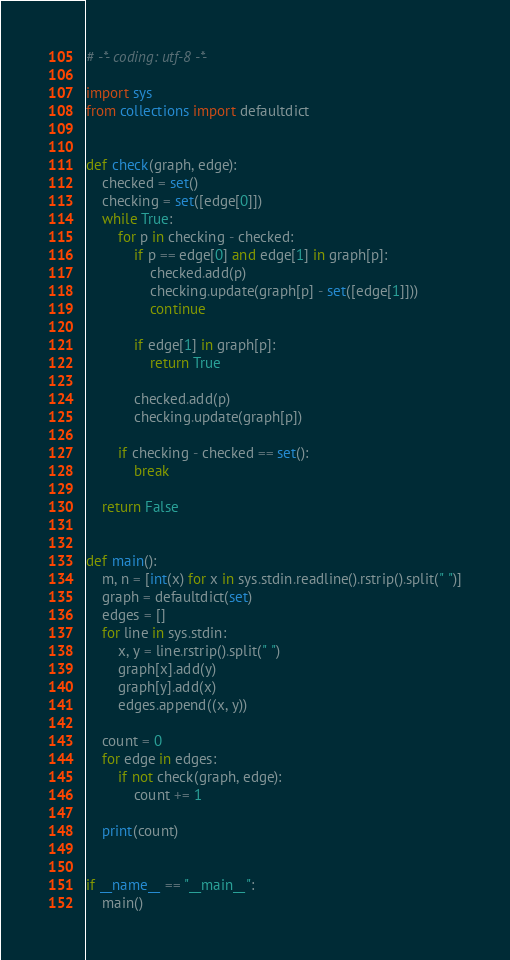<code> <loc_0><loc_0><loc_500><loc_500><_Python_># -*- coding: utf-8 -*-

import sys
from collections import defaultdict


def check(graph, edge):
    checked = set()
    checking = set([edge[0]])
    while True:
        for p in checking - checked:
            if p == edge[0] and edge[1] in graph[p]:
                checked.add(p)
                checking.update(graph[p] - set([edge[1]]))
                continue

            if edge[1] in graph[p]:
                return True

            checked.add(p)
            checking.update(graph[p])

        if checking - checked == set():
            break

    return False


def main():
    m, n = [int(x) for x in sys.stdin.readline().rstrip().split(" ")]
    graph = defaultdict(set)
    edges = []
    for line in sys.stdin:
        x, y = line.rstrip().split(" ")
        graph[x].add(y)
        graph[y].add(x)
        edges.append((x, y))

    count = 0
    for edge in edges:
        if not check(graph, edge):
            count += 1

    print(count)


if __name__ == "__main__":
    main()
</code> 